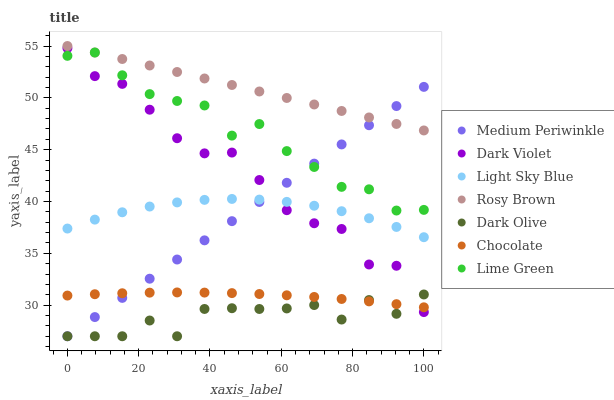Does Dark Olive have the minimum area under the curve?
Answer yes or no. Yes. Does Rosy Brown have the maximum area under the curve?
Answer yes or no. Yes. Does Medium Periwinkle have the minimum area under the curve?
Answer yes or no. No. Does Medium Periwinkle have the maximum area under the curve?
Answer yes or no. No. Is Rosy Brown the smoothest?
Answer yes or no. Yes. Is Dark Olive the roughest?
Answer yes or no. Yes. Is Medium Periwinkle the smoothest?
Answer yes or no. No. Is Medium Periwinkle the roughest?
Answer yes or no. No. Does Dark Olive have the lowest value?
Answer yes or no. Yes. Does Dark Violet have the lowest value?
Answer yes or no. No. Does Rosy Brown have the highest value?
Answer yes or no. Yes. Does Medium Periwinkle have the highest value?
Answer yes or no. No. Is Dark Olive less than Rosy Brown?
Answer yes or no. Yes. Is Rosy Brown greater than Chocolate?
Answer yes or no. Yes. Does Light Sky Blue intersect Dark Violet?
Answer yes or no. Yes. Is Light Sky Blue less than Dark Violet?
Answer yes or no. No. Is Light Sky Blue greater than Dark Violet?
Answer yes or no. No. Does Dark Olive intersect Rosy Brown?
Answer yes or no. No. 